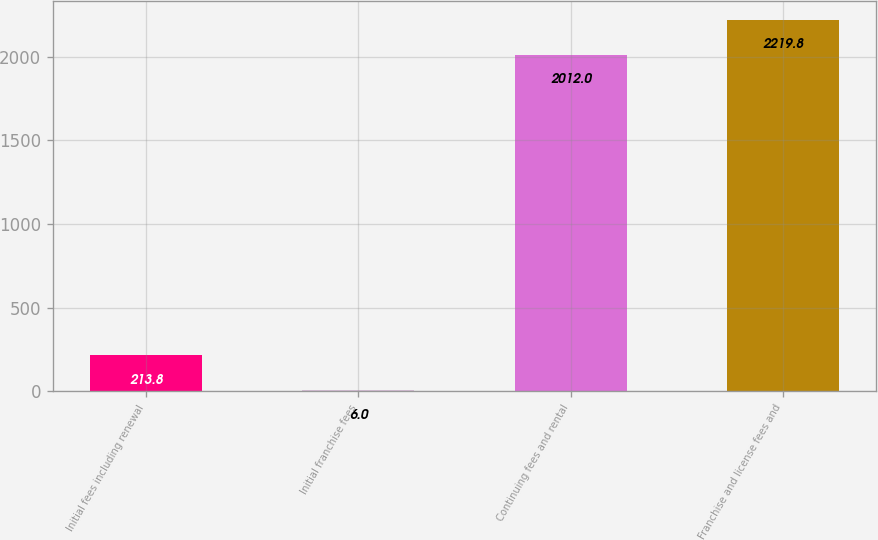Convert chart to OTSL. <chart><loc_0><loc_0><loc_500><loc_500><bar_chart><fcel>Initial fees including renewal<fcel>Initial franchise fees<fcel>Continuing fees and rental<fcel>Franchise and license fees and<nl><fcel>213.8<fcel>6<fcel>2012<fcel>2219.8<nl></chart> 